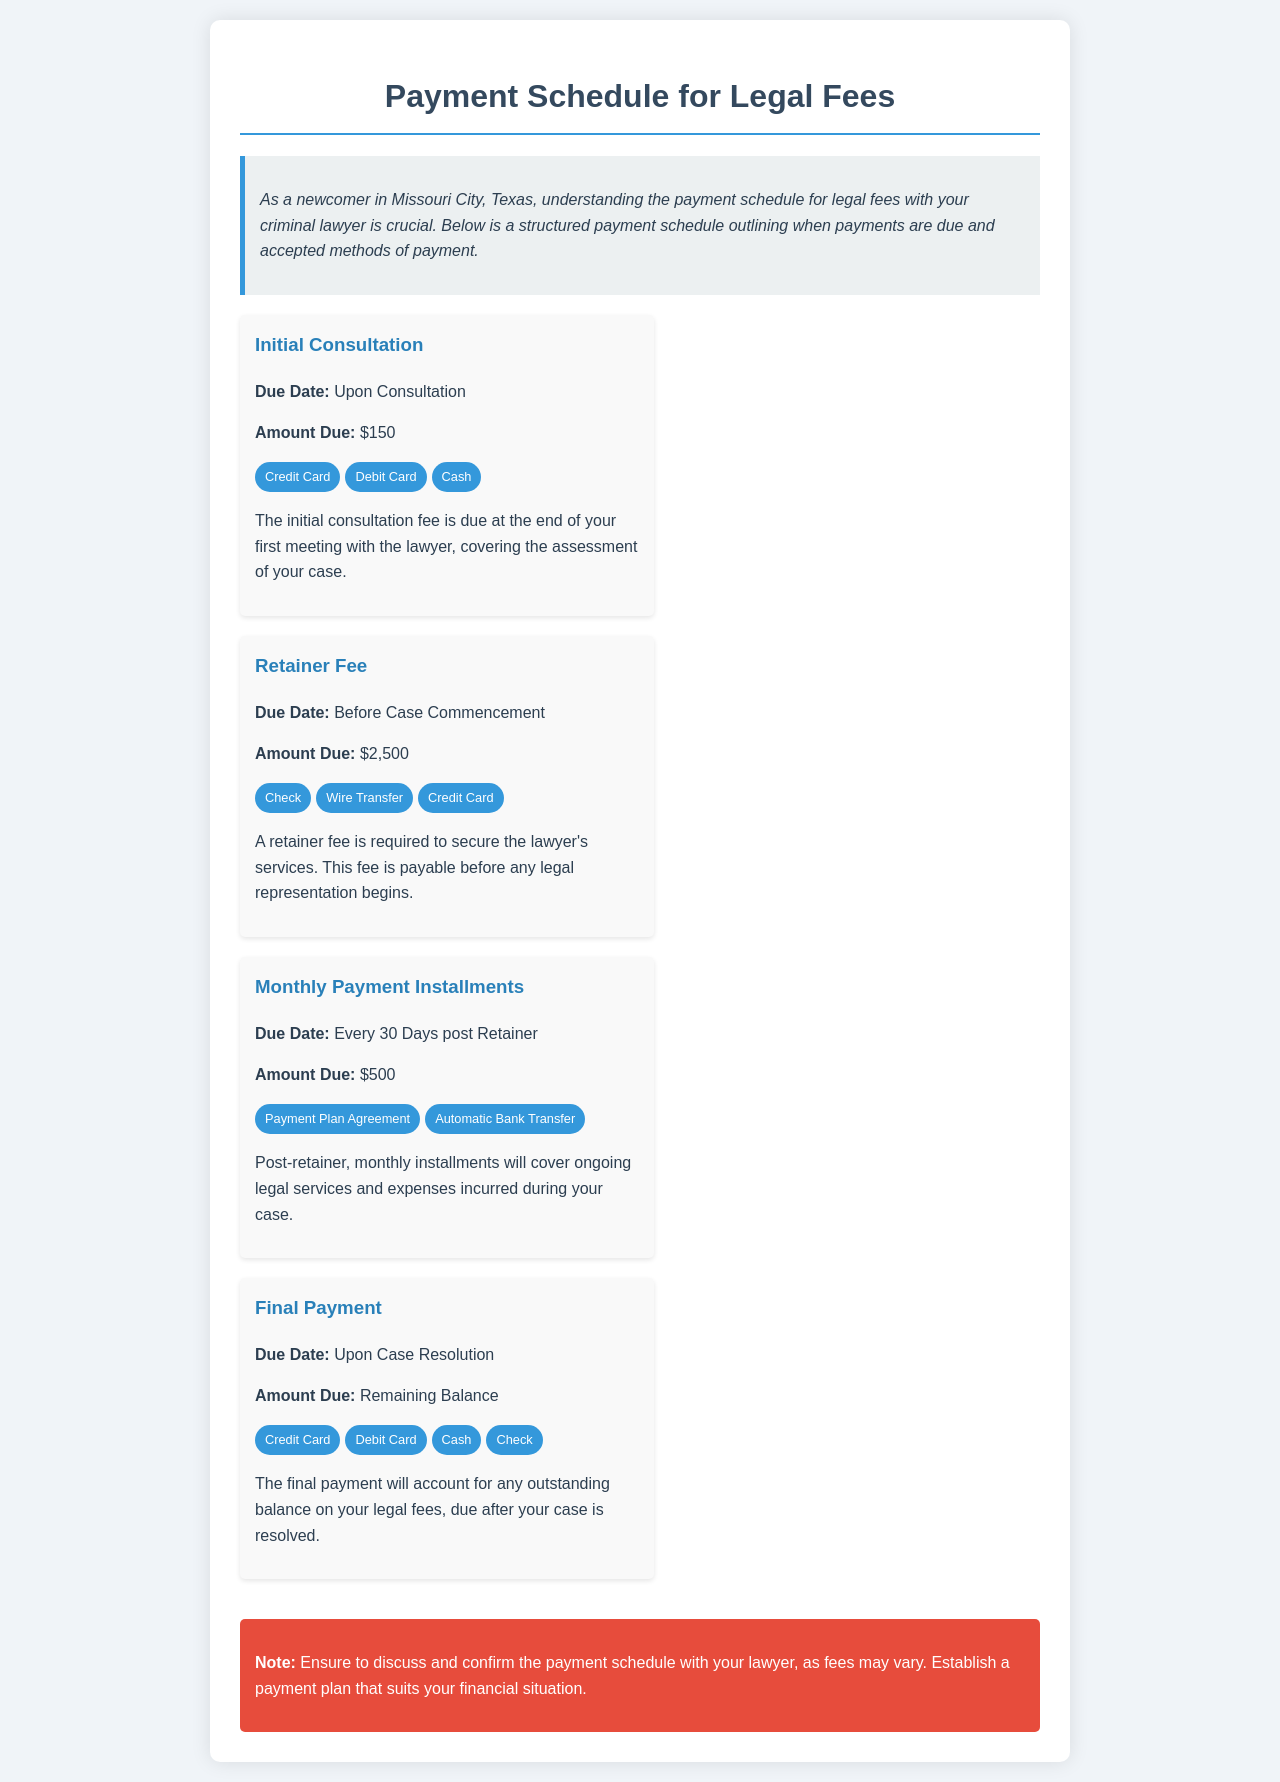What is the fee for the initial consultation? The document states that the fee due at the end of the first meeting with the lawyer is $150.
Answer: $150 When is the retainer fee due? The document specifies that the retainer fee is due before any legal representation begins.
Answer: Before Case Commencement How much is the monthly installment? According to the schedule, the monthly installment after the retainer fee is $500.
Answer: $500 What payment methods are accepted for the initial consultation? The document lists three payment methods: Credit Card, Debit Card, and Cash for the initial consultation.
Answer: Credit Card, Debit Card, Cash When is the final payment due? The final payment is due upon case resolution, as stated in the document.
Answer: Upon Case Resolution What is the total amount due for the retainer fee? The document specifies that the amount due for the retainer fee is $2,500.
Answer: $2,500 How often are monthly installments due? The document indicates that monthly installments are due every 30 days after the retainer fee.
Answer: Every 30 Days post Retainer What should you confirm with your lawyer regarding payments? The document advises to discuss and confirm the payment schedule with your lawyer.
Answer: Payment schedule What payment methods are allowed for the final payment? The document states that for the final payment, Credit Card, Debit Card, Cash, and Check are accepted.
Answer: Credit Card, Debit Card, Cash, Check 